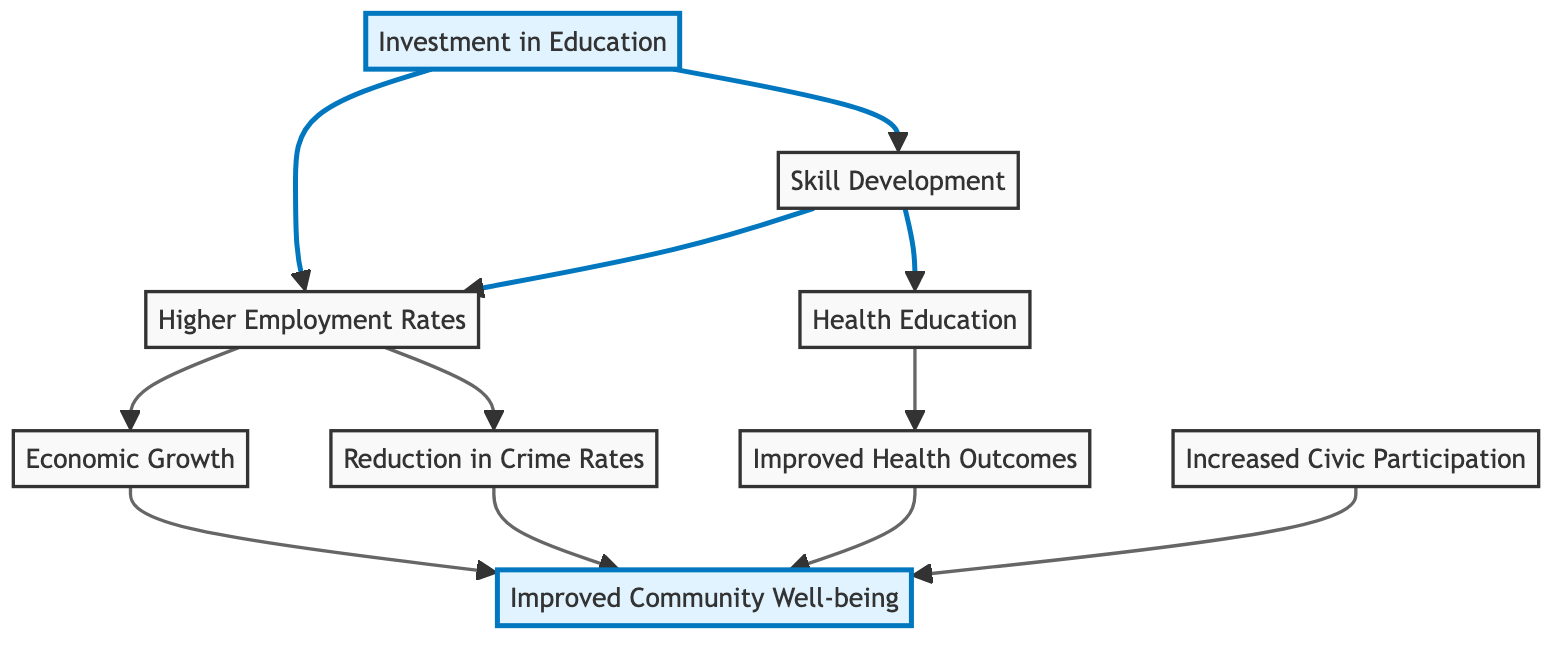What is the first block in the diagram? The first block is labeled "Investment in Education," which is the starting point of the diagram and represents the initial investment that leads to further outcomes.
Answer: Investment in Education How many blocks are in the diagram? By counting the blocks listed in the diagram, there are a total of eight distinct blocks, each representing different concepts connected to education and community well-being.
Answer: 8 What are the two outcomes connected to "Higher Employment Rates"? The outcomes connected to "Higher Employment Rates" are "Economic Growth" and "Reduction in Crime Rates," indicating the positive results of increased employment opportunities in the community.
Answer: Economic Growth, Reduction in Crime Rates Which block is connected to both "Skill Development" and "Health Education"? The block "Skill Development" is connected to "Higher Employment Rates" and "Health Education," showcasing the direct link between developing skills and education related to health.
Answer: Health Education How does "Investment in Education" lead to "Improved Community Well-being"? "Investment in Education" leads to "Improved Community Well-being" through several intermediary blocks: it first enhances "Skill Development" and "Higher Employment Rates," which both connect to "Economic Growth" and "Reduction in Crime Rates" – all of which ultimately contribute to improved community outcomes.
Answer: Through skill development, employment, economic growth, and reduced crime What block directly influences "Improved Health Outcomes"? The block that directly influences "Improved Health Outcomes" is "Health Education." This indicates that educational initiatives focused on health can lead to better health results in the community.
Answer: Health Education Which two blocks impact "Community Well-being" via health-related benefits? The two blocks that impact "Community Well-being" via health-related benefits are "Improved Health Outcomes" and "Health Education," illustrating the relationship between health education and overall community health and well-being.
Answer: Improved Health Outcomes, Health Education What is the connection between "Higher Employment Rates" and "Reduction in Crime Rates"? "Higher Employment Rates" are directly connected to "Reduction in Crime Rates," indicating that as employment opportunities increase in the community, crime rates tend to decrease.
Answer: Direct connection Which block is a result of both "Economic Growth" and "Reduced Crime"? The block that results from both "Economic Growth" and "Reduced Crime" is "Improved Community Well-being," which highlights the cumulative positive impact of both economic factors and safety on community health.
Answer: Improved Community Well-being 